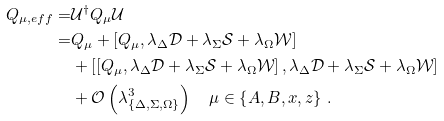<formula> <loc_0><loc_0><loc_500><loc_500>Q _ { \mu , e f f } = & \mathcal { U } ^ { \dagger } Q _ { \mu } \mathcal { U } \\ = & Q _ { \mu } + \left [ Q _ { \mu } , \lambda _ { \Delta } \mathcal { D } + \lambda _ { \Sigma } \mathcal { S } + \lambda _ { \Omega } \mathcal { W } \right ] \\ & + \left [ \left [ Q _ { \mu } , \lambda _ { \Delta } \mathcal { D } + \lambda _ { \Sigma } \mathcal { S } + \lambda _ { \Omega } \mathcal { W } \right ] , \lambda _ { \Delta } \mathcal { D } + \lambda _ { \Sigma } \mathcal { S } + \lambda _ { \Omega } \mathcal { W } \right ] \\ & + \mathcal { O } \left ( \lambda _ { \{ \Delta , \Sigma , \Omega \} } ^ { 3 } \right ) \quad \mu \in \left \{ A , B , x , z \right \} \, .</formula> 